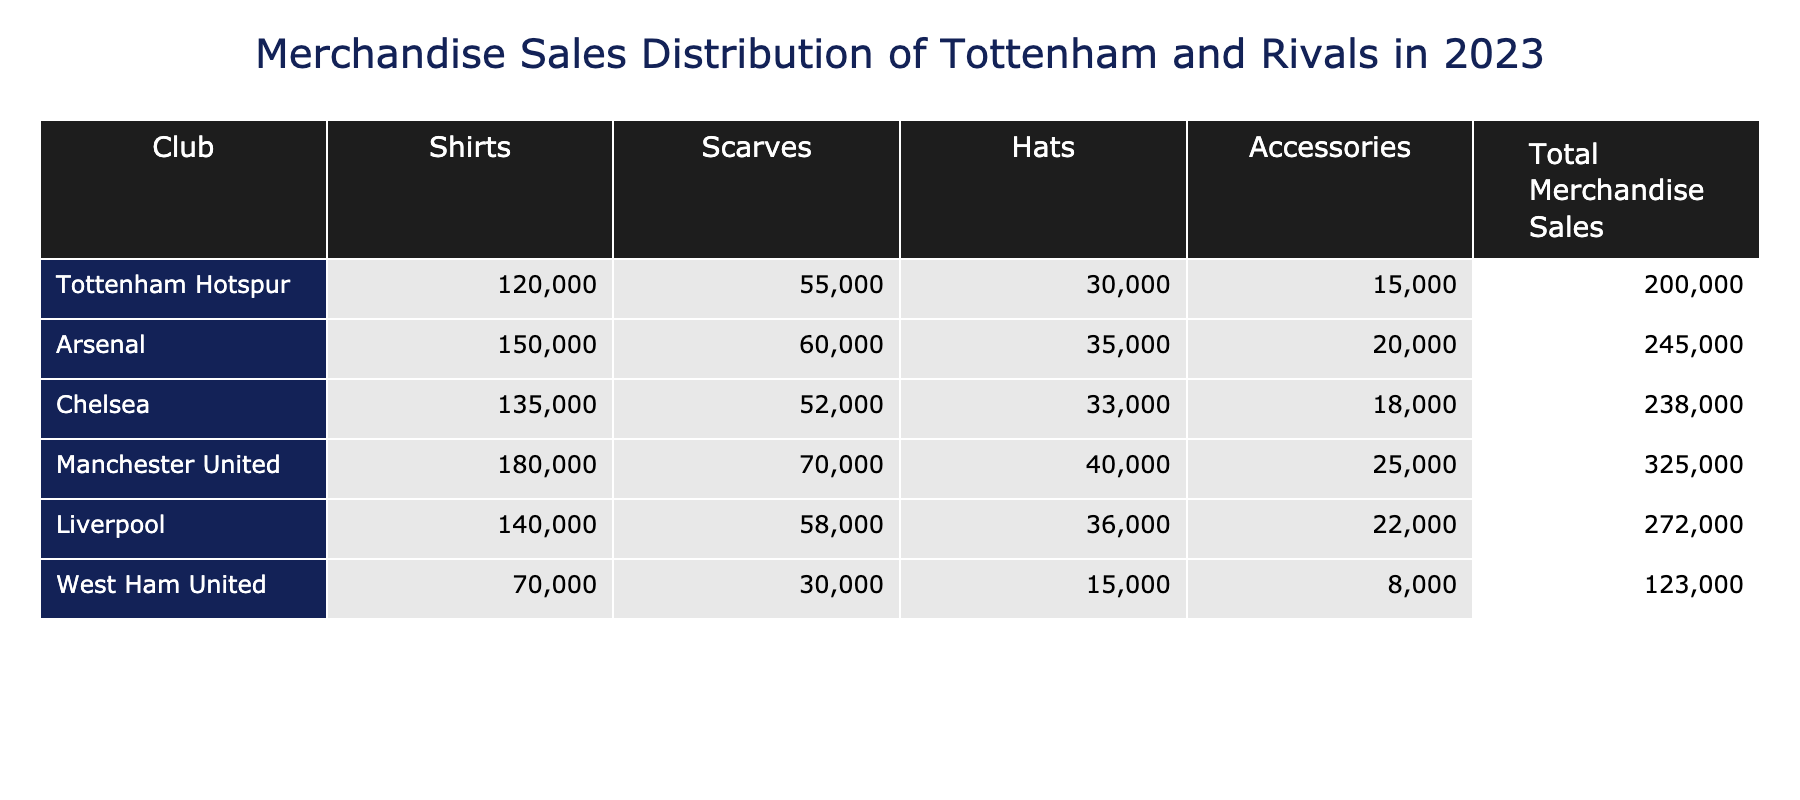What is the total merchandise sales for Tottenham Hotspur? The table shows the total merchandise sales for Tottenham Hotspur, which is listed as 200,000.
Answer: 200,000 Which club sold the most shirts in 2023? According to the table, Manchester United sold the most shirts with a total of 180,000, which is higher than the other clubs listed.
Answer: Manchester United What is the difference in total merchandise sales between Arsenal and West Ham United? The total merchandise sales for Arsenal is 245,000 and for West Ham United it is 123,000. The difference is calculated as 245,000 - 123,000 = 122,000.
Answer: 122,000 Did Chelsea sell more accessories than Tottenham? The table shows Chelsea's accessories sales as 18,000 while Tottenham's accessories sales are 15,000. Since 18,000 is greater than 15,000, the answer is yes.
Answer: Yes What is the average number of scarves sold by the clubs in the table? The total number of scarves sold can be calculated by summing them: 55,000 (Tottenham) + 60,000 (Arsenal) + 52,000 (Chelsea) + 70,000 (Manchester United) + 58,000 (Liverpool) + 30,000 (West Ham) = 325,000. Since there are 6 clubs, the average is 325,000 / 6 = 54,167.
Answer: 54,167 Which club has the lowest total merchandise sales and what is that value? By reviewing the total merchandise sales in the last column, West Ham United has the lowest sales figure of 123,000.
Answer: West Ham United, 123,000 How many more hats did Liverpool sell compared to Tottenham? Liverpool sold 36,000 hats, while Tottenham sold 30,000. The difference is 36,000 - 30,000 = 6,000.
Answer: 6,000 What percentage of Manchester United's total sales came from shirts? Manchester United's sales from shirts amount to 180,000. The total merchandise sales are 325,000. The percentage is calculated as (180,000 / 325,000) * 100 ≈ 55.38%.
Answer: Approximately 55.38% Which club has a higher combined sales of scarves and accessories, Arsenal or Liverpool? Arsenal's sales of scarves and accessories total to 60,000 + 20,000 = 80,000. For Liverpool, it’s 58,000 + 22,000 = 80,000. Since both totals are equal at 80,000, it indicates neither has higher combined sales; they are the same.
Answer: Neither, both are equal at 80,000 